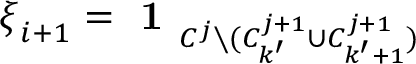<formula> <loc_0><loc_0><loc_500><loc_500>\xi _ { i + 1 } = 1 _ { C ^ { j } \ ( C _ { k ^ { \prime } } ^ { j + 1 } \cup C _ { k ^ { \prime } + 1 } ^ { j + 1 } ) }</formula> 